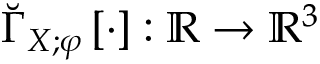Convert formula to latex. <formula><loc_0><loc_0><loc_500><loc_500>\breve { \Gamma } _ { X ; \varphi } \left [ \cdot \right ] \colon \mathbb { R } \to \mathbb { R } ^ { 3 }</formula> 